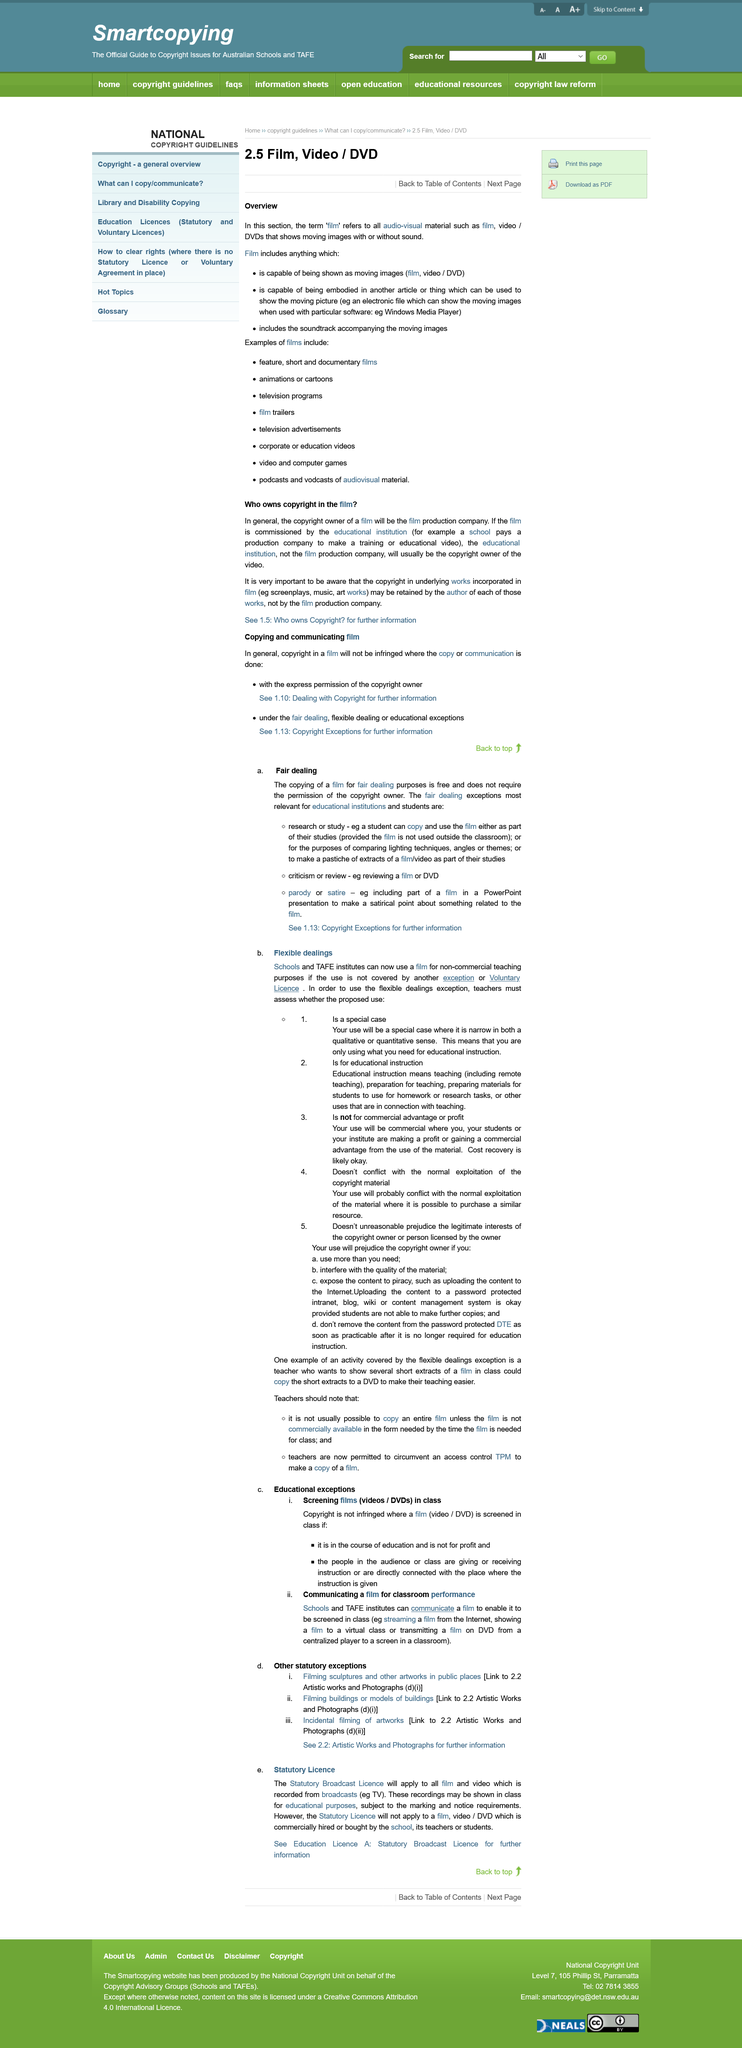Highlight a few significant elements in this photo. Videos and DVDs can be shown in a classroom setting by streaming from the internet, presenting to a virtual class, or transmitting remotely to a screen. The copying of a film for fair dealing purposes is free. It is not a violation of copyright to screen a film in a classroom setting for the purpose of education and not for profit. It is not required to obtain the permission of the copyright owner for the copying of a film for fair dealing purposes," said the court. The legitimate audience in a classroom situation is comprised of students, teachers, and individuals directly connected with the establishment. 